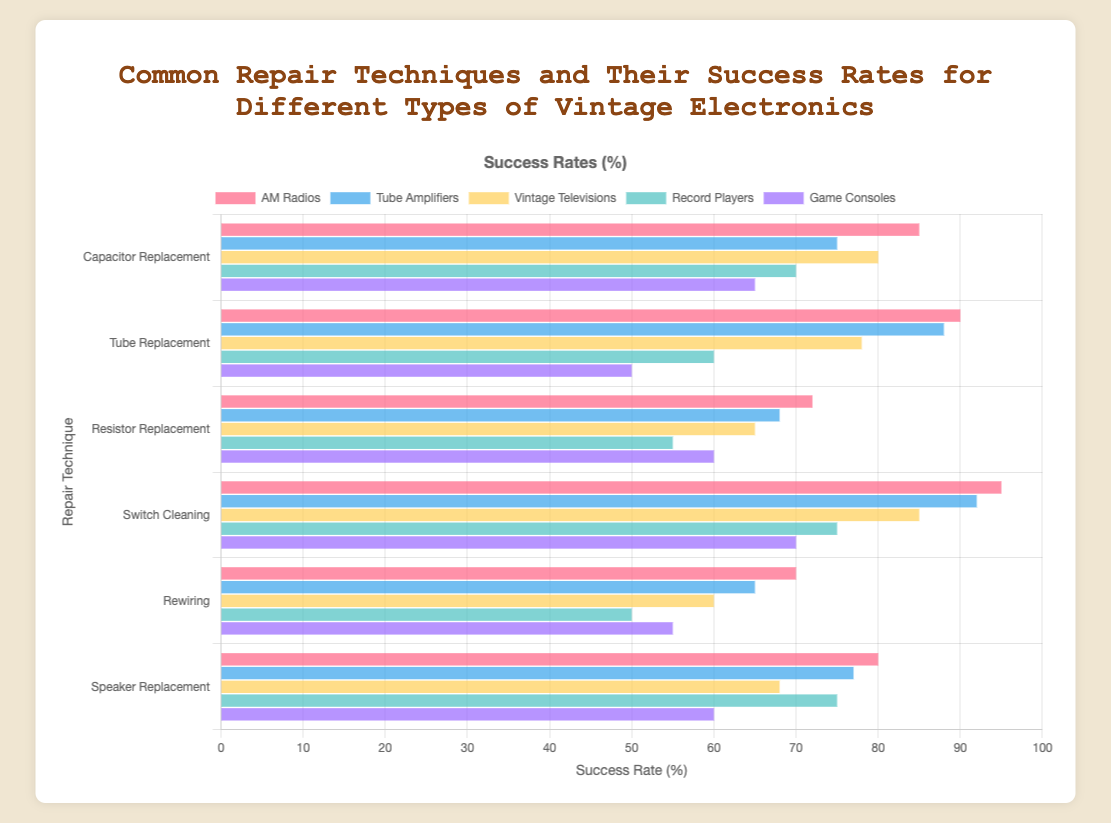How many repair techniques have a success rate of at least 75% for AM Radios? Identify all the repair techniques for AM Radios and count those with a success rate of at least 75%. These are Capacitor Replacement (85%), Tube Replacement (90%), Switch Cleaning (95%), and Speaker Replacement (80%). There are 4 such techniques.
Answer: 4 Which repair technique has the highest success rate for Tube Amplifiers? Look at the success rates for each repair technique with respect to Tube Amplifiers. The highest success rate is for Switch Cleaning, which is 92%.
Answer: Switch Cleaning What is the average success rate of Rewiring for all types of vintage electronics? Sum the success rates of Rewiring for all categories and then divide by the number of categories. (70 + 65 + 60 + 50 + 55) / 5 = 60%
Answer: 60% Which repair technique has the lowest success rate for Game Consoles, and what is that rate? Compare the success rates for Game Consoles across all repair techniques. The lowest is Tube Replacement with a success rate of 50%.
Answer: Tube Replacement, 50% What is the total success rate of Capacitor Replacement for AM Radios and Vintage Televisions combined? Add the success rates of Capacitor Replacement for AM Radios (85%) and Vintage Televisions (80%). 85 + 80 = 165%
Answer: 165% For which vintage electronic type does Resistor Replacement have the equal success rate with Speaker Replacement? Compare the success rates of Resistor Replacement and Speaker Replacement across all categories. They are equal at 75% for Record Players.
Answer: Record Players How does the success rate of Switch Cleaning for AM Radios compare to the success rate of Rewiring for the same? Compare the two success rates for AM Radios: Switch Cleaning (95%) and Rewiring (70%). Switch Cleaning is higher by 25%.
Answer: Switch Cleaning is higher by 25% If you wanted to improve the success rate of Game Consoles, which repair technique would you most likely avoid based on the given data? Identify the repair technique with the lowest success rate for Game Consoles. This is Tube Replacement with a 50% success rate.
Answer: Tube Replacement What is the difference in the success rates of Tube Replacement for AM Radios and Game Consoles? Subtract the success rate of Tube Replacement for Game Consoles from that of AM Radios. 90 - 50 = 40%
Answer: 40% Of all the repair techniques, which one shows the most consistent success rate across different electronics (smallest range)? Calculate the range of success rates for each repair technique across all electronics types, then identify the smallest range. Resistor Replacement ranges from 55% to 72%, a difference of 17%.
Answer: Resistor Replacement has the smallest range of 17% 